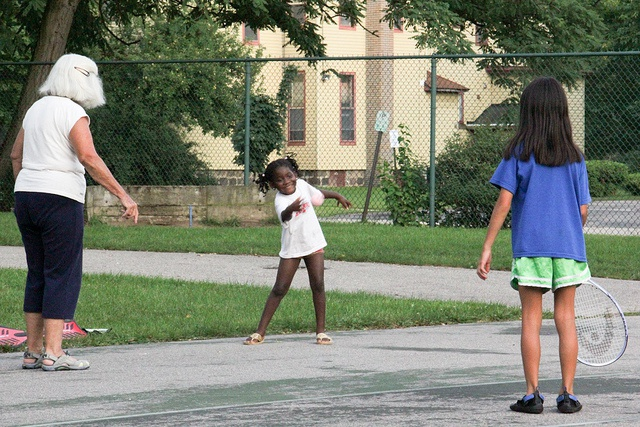Describe the objects in this image and their specific colors. I can see people in black, blue, brown, and salmon tones, people in black, lightgray, lightpink, and gray tones, people in black, lightgray, gray, and maroon tones, tennis racket in black, lightgray, and darkgray tones, and sports ball in black, pink, tan, and olive tones in this image. 